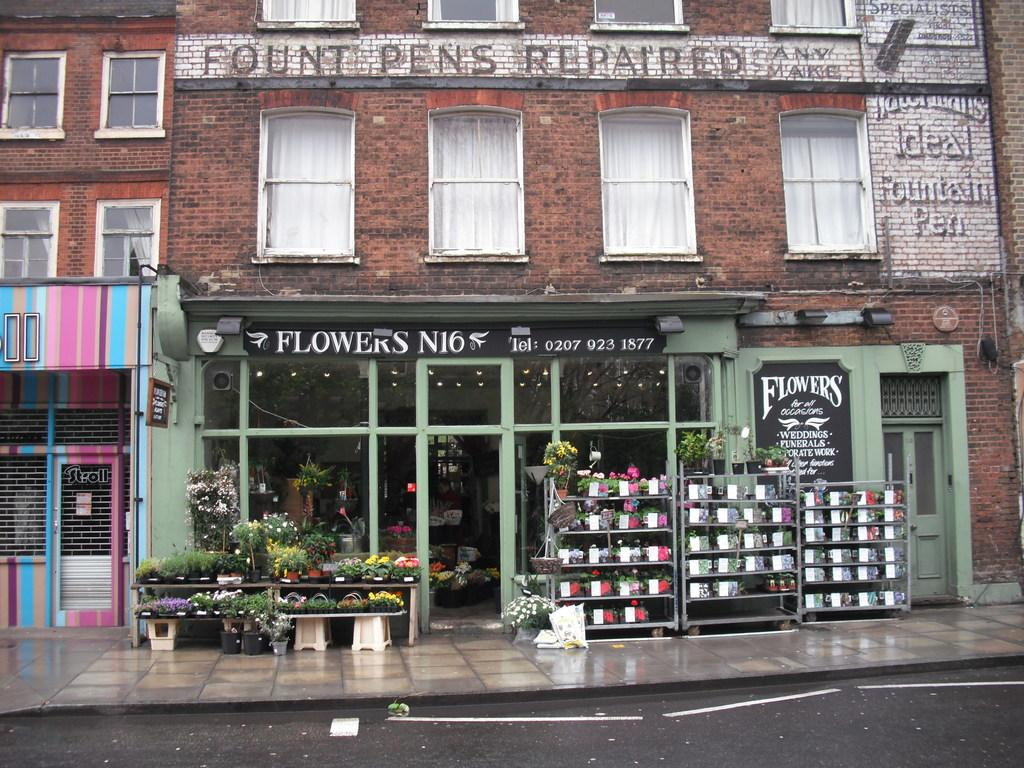<image>
Give a short and clear explanation of the subsequent image. Pots of flowers are outside the Flowers N16 storefront. 